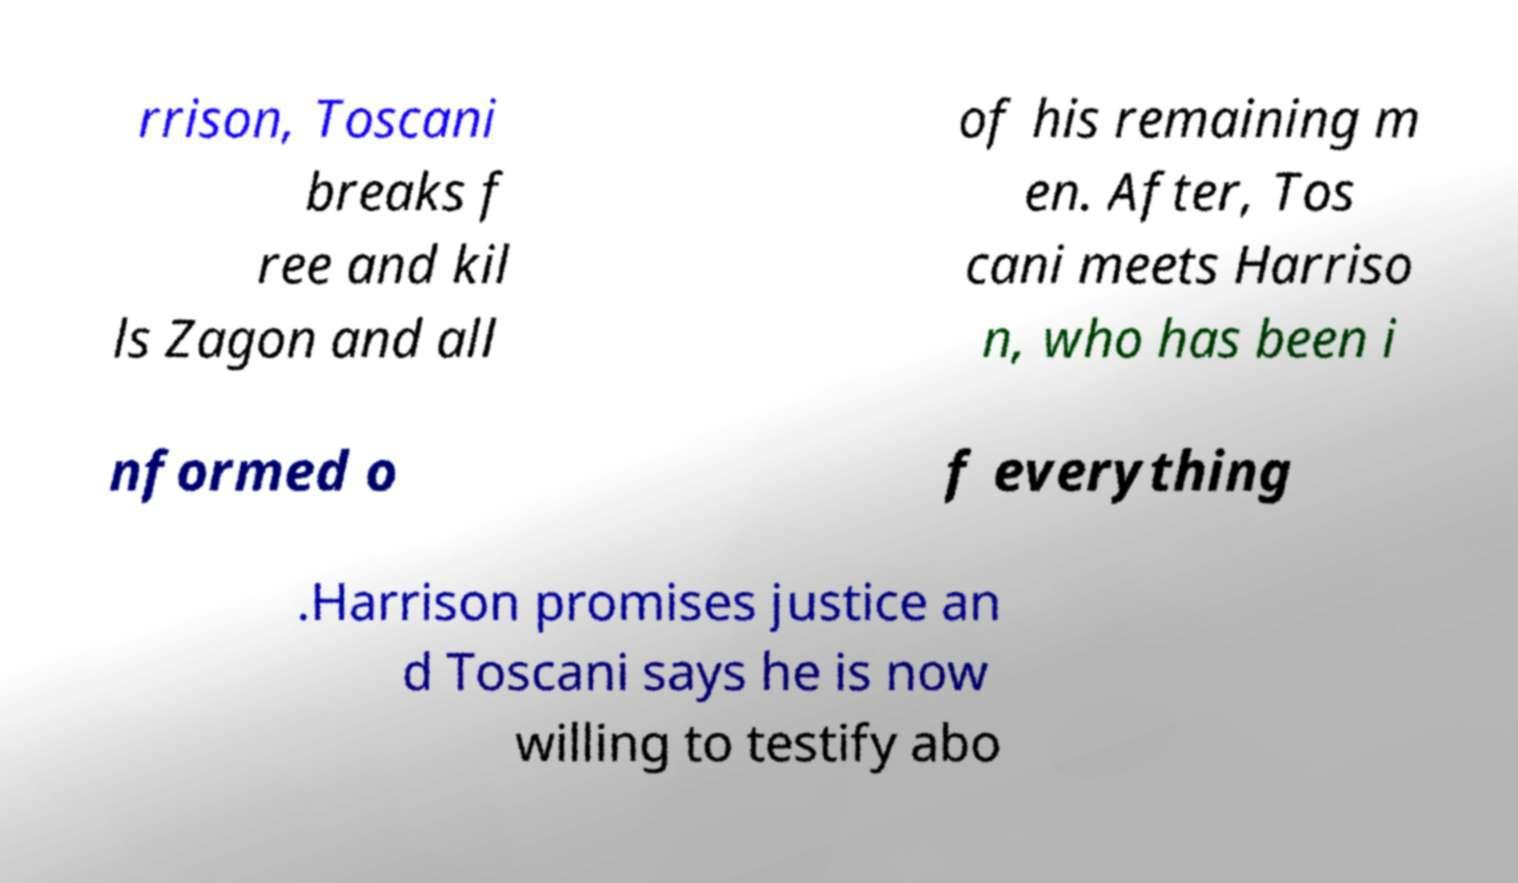I need the written content from this picture converted into text. Can you do that? rrison, Toscani breaks f ree and kil ls Zagon and all of his remaining m en. After, Tos cani meets Harriso n, who has been i nformed o f everything .Harrison promises justice an d Toscani says he is now willing to testify abo 